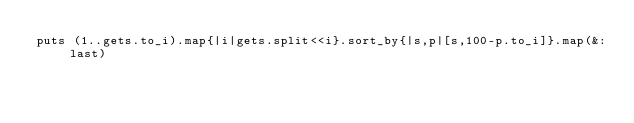<code> <loc_0><loc_0><loc_500><loc_500><_Ruby_>puts (1..gets.to_i).map{|i|gets.split<<i}.sort_by{|s,p|[s,100-p.to_i]}.map(&:last)</code> 